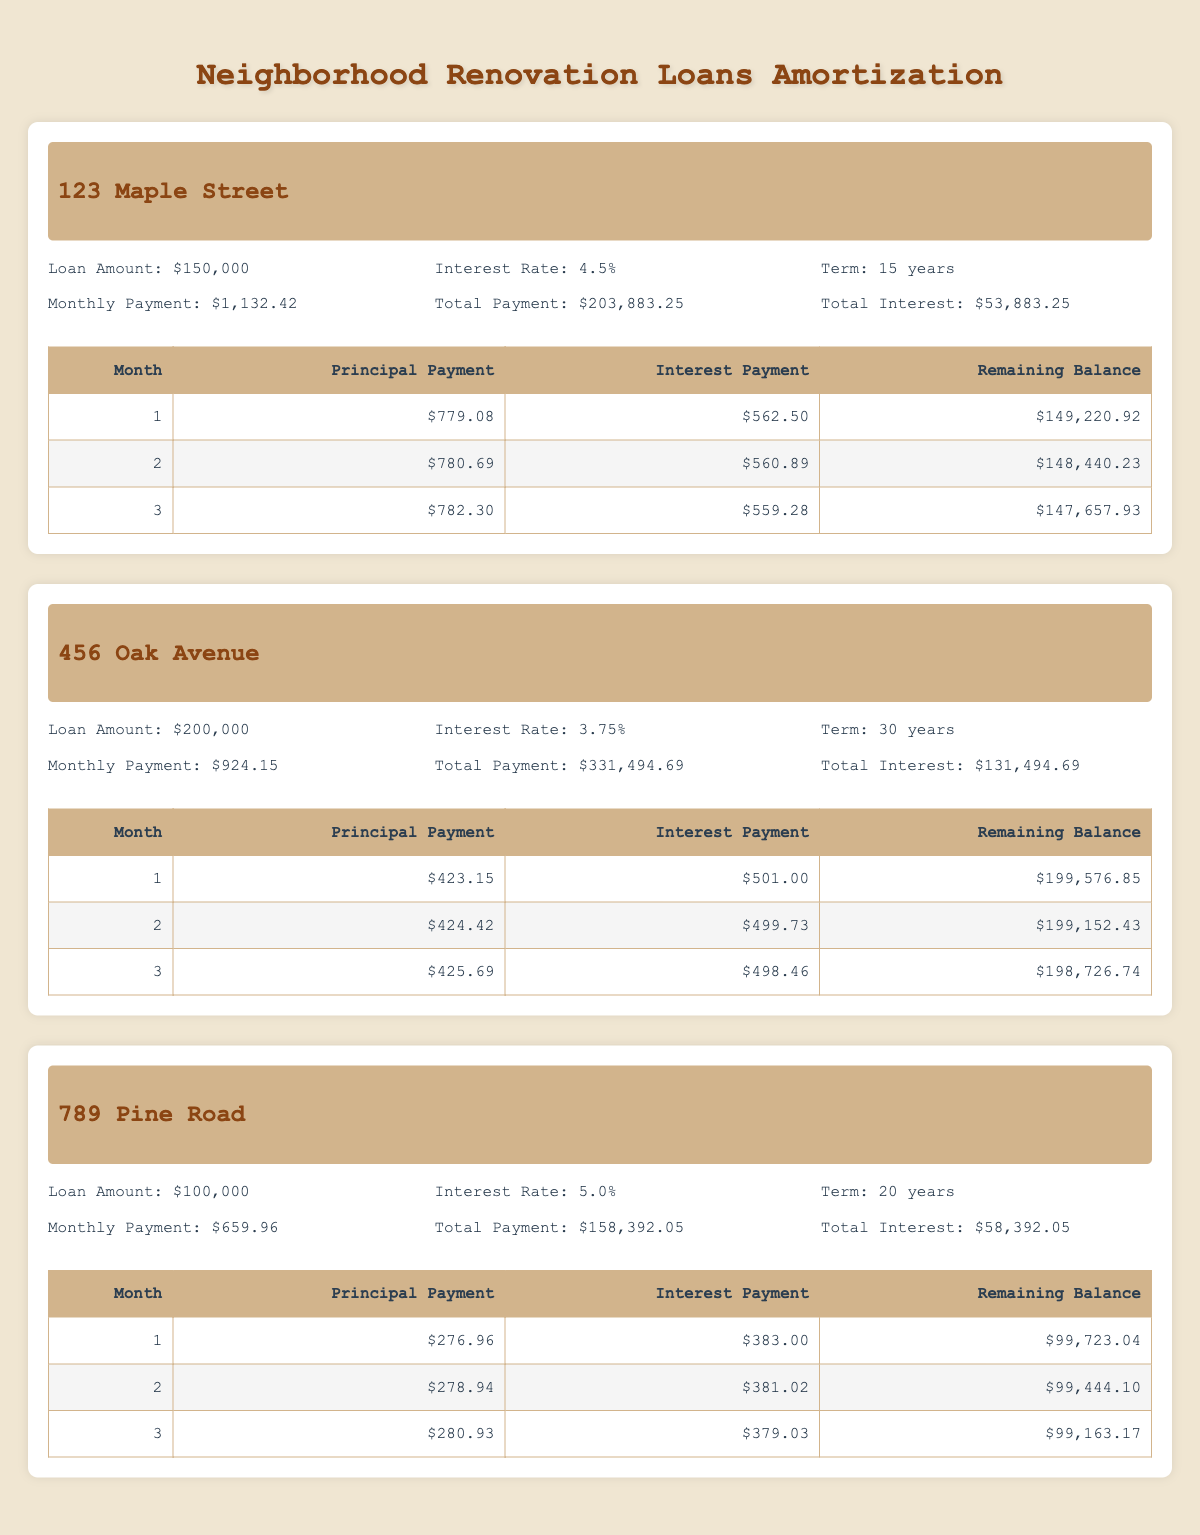What is the total loan amount for the property at 456 Oak Avenue? The total loan amount for 456 Oak Avenue is clearly stated in the table as $200,000.
Answer: 200,000 What is the monthly payment for the property at 789 Pine Road? The monthly payment for 789 Pine Road is listed in the table as $659.96.
Answer: 659.96 Is the total interest paid for the loan on 123 Maple Street greater than $50,000? The total interest paid for 123 Maple Street is $53,883.25. Since $53,883.25 is greater than $50,000, the answer is yes.
Answer: Yes How much is the principal payment in the second month for the loan at 456 Oak Avenue? The principal payment in the second month for 456 Oak Avenue is found in the breakdown section and is $424.42.
Answer: 424.42 Which property has the lowest total payment over the life of the loan? To find the lowest total payment, we compare the total payment figures: 123 Maple Street is $203,883.25, 456 Oak Avenue is $331,494.69, and 789 Pine Road is $158,392.05. The lowest of these is $158,392.05 for 789 Pine Road.
Answer: 789 Pine Road What is the remaining balance after the first month for the loan at 123 Maple Street? The remaining balance after the first month for 123 Maple Street is directly stated in the breakdown as $149,220.92.
Answer: 149,220.92 Does the loan term for 456 Oak Avenue exceed 20 years? The loan term for 456 Oak Avenue is 30 years, which does exceed 20 years. Thus, the answer is yes.
Answer: Yes Calculate the total interest paid for both properties, 123 Maple Street and 789 Pine Road. The total interest for 123 Maple Street is $53,883.25 and for 789 Pine Road is $58,392.05. Adding these amounts gives $53,883.25 + $58,392.05 = $112,275.30 total interest paid for both properties.
Answer: 112,275.30 What percentage of the first month's payment for 789 Pine Road is allocated to principal? The first month's payment is summed up as $276.96 (principal) + $383.00 (interest) = $659.96 (total). To find the percentage of the principal: ($276.96 / $659.96) * 100 = 41.92%.
Answer: 41.92% 